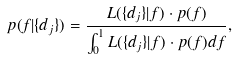<formula> <loc_0><loc_0><loc_500><loc_500>p ( f | \{ d _ { j } \} ) = \frac { L ( \{ d _ { j } \} | f ) \cdot p ( f ) } { \int _ { 0 } ^ { 1 } L ( \{ d _ { j } \} | f ) \cdot p ( f ) d f } ,</formula> 